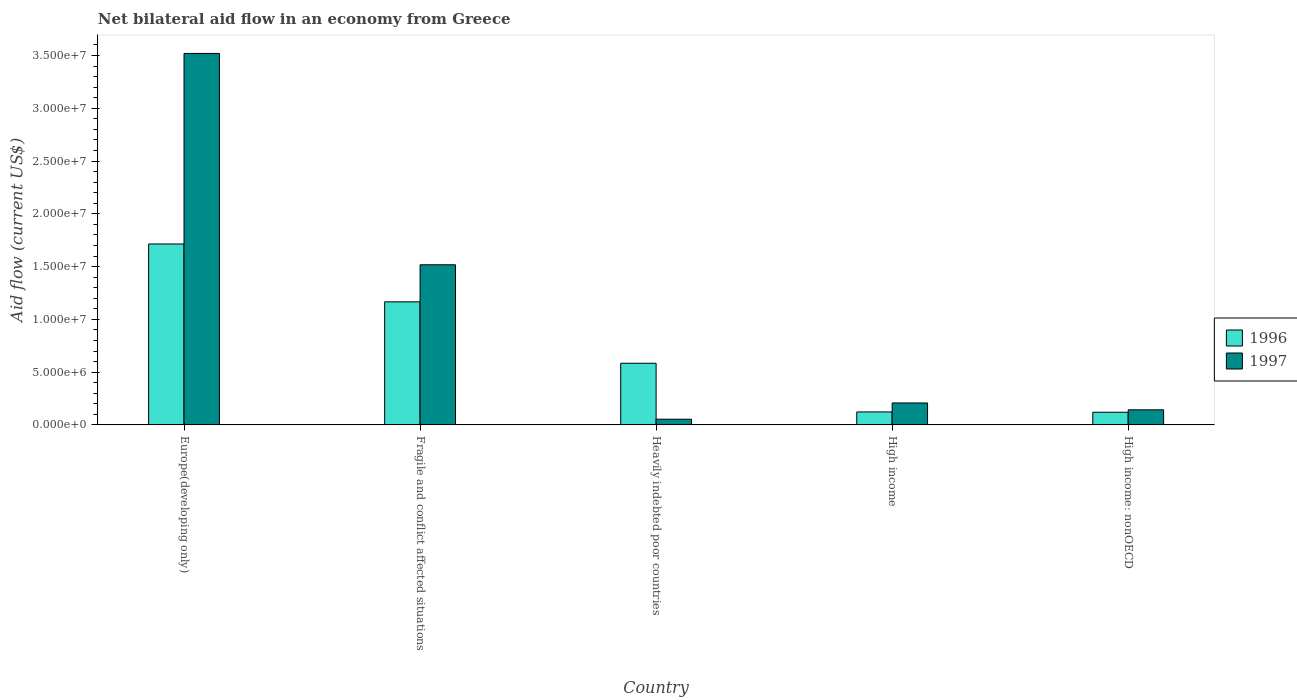Are the number of bars per tick equal to the number of legend labels?
Your answer should be very brief. Yes. Are the number of bars on each tick of the X-axis equal?
Your response must be concise. Yes. How many bars are there on the 4th tick from the left?
Keep it short and to the point. 2. What is the label of the 3rd group of bars from the left?
Ensure brevity in your answer.  Heavily indebted poor countries. In how many cases, is the number of bars for a given country not equal to the number of legend labels?
Ensure brevity in your answer.  0. What is the net bilateral aid flow in 1997 in Europe(developing only)?
Keep it short and to the point. 3.52e+07. Across all countries, what is the maximum net bilateral aid flow in 1996?
Provide a succinct answer. 1.71e+07. Across all countries, what is the minimum net bilateral aid flow in 1997?
Your answer should be very brief. 5.40e+05. In which country was the net bilateral aid flow in 1996 maximum?
Your answer should be compact. Europe(developing only). In which country was the net bilateral aid flow in 1996 minimum?
Provide a succinct answer. High income: nonOECD. What is the total net bilateral aid flow in 1997 in the graph?
Make the answer very short. 5.44e+07. What is the difference between the net bilateral aid flow in 1997 in Fragile and conflict affected situations and that in High income?
Ensure brevity in your answer.  1.31e+07. What is the difference between the net bilateral aid flow in 1996 in Heavily indebted poor countries and the net bilateral aid flow in 1997 in Europe(developing only)?
Offer a terse response. -2.94e+07. What is the average net bilateral aid flow in 1997 per country?
Ensure brevity in your answer.  1.09e+07. What is the difference between the net bilateral aid flow of/in 1997 and net bilateral aid flow of/in 1996 in Fragile and conflict affected situations?
Offer a terse response. 3.51e+06. In how many countries, is the net bilateral aid flow in 1997 greater than 2000000 US$?
Provide a succinct answer. 3. What is the ratio of the net bilateral aid flow in 1996 in High income to that in High income: nonOECD?
Your answer should be very brief. 1.02. Is the net bilateral aid flow in 1996 in Europe(developing only) less than that in Fragile and conflict affected situations?
Offer a very short reply. No. Is the difference between the net bilateral aid flow in 1997 in Fragile and conflict affected situations and High income: nonOECD greater than the difference between the net bilateral aid flow in 1996 in Fragile and conflict affected situations and High income: nonOECD?
Offer a very short reply. Yes. What is the difference between the highest and the second highest net bilateral aid flow in 1997?
Offer a very short reply. 3.31e+07. What is the difference between the highest and the lowest net bilateral aid flow in 1997?
Provide a succinct answer. 3.46e+07. Is the sum of the net bilateral aid flow in 1997 in Heavily indebted poor countries and High income greater than the maximum net bilateral aid flow in 1996 across all countries?
Ensure brevity in your answer.  No. What does the 2nd bar from the left in Europe(developing only) represents?
Ensure brevity in your answer.  1997. How many bars are there?
Your answer should be very brief. 10. Are all the bars in the graph horizontal?
Your response must be concise. No. What is the difference between two consecutive major ticks on the Y-axis?
Provide a succinct answer. 5.00e+06. Where does the legend appear in the graph?
Keep it short and to the point. Center right. How are the legend labels stacked?
Ensure brevity in your answer.  Vertical. What is the title of the graph?
Your response must be concise. Net bilateral aid flow in an economy from Greece. What is the label or title of the Y-axis?
Your answer should be compact. Aid flow (current US$). What is the Aid flow (current US$) of 1996 in Europe(developing only)?
Provide a short and direct response. 1.71e+07. What is the Aid flow (current US$) in 1997 in Europe(developing only)?
Offer a very short reply. 3.52e+07. What is the Aid flow (current US$) of 1996 in Fragile and conflict affected situations?
Offer a very short reply. 1.17e+07. What is the Aid flow (current US$) of 1997 in Fragile and conflict affected situations?
Provide a short and direct response. 1.52e+07. What is the Aid flow (current US$) in 1996 in Heavily indebted poor countries?
Provide a succinct answer. 5.84e+06. What is the Aid flow (current US$) in 1997 in Heavily indebted poor countries?
Ensure brevity in your answer.  5.40e+05. What is the Aid flow (current US$) in 1996 in High income?
Keep it short and to the point. 1.23e+06. What is the Aid flow (current US$) in 1997 in High income?
Provide a succinct answer. 2.08e+06. What is the Aid flow (current US$) in 1996 in High income: nonOECD?
Ensure brevity in your answer.  1.20e+06. What is the Aid flow (current US$) of 1997 in High income: nonOECD?
Your response must be concise. 1.43e+06. Across all countries, what is the maximum Aid flow (current US$) in 1996?
Ensure brevity in your answer.  1.71e+07. Across all countries, what is the maximum Aid flow (current US$) in 1997?
Make the answer very short. 3.52e+07. Across all countries, what is the minimum Aid flow (current US$) in 1996?
Your answer should be compact. 1.20e+06. Across all countries, what is the minimum Aid flow (current US$) of 1997?
Provide a short and direct response. 5.40e+05. What is the total Aid flow (current US$) in 1996 in the graph?
Ensure brevity in your answer.  3.71e+07. What is the total Aid flow (current US$) of 1997 in the graph?
Provide a succinct answer. 5.44e+07. What is the difference between the Aid flow (current US$) of 1996 in Europe(developing only) and that in Fragile and conflict affected situations?
Offer a very short reply. 5.48e+06. What is the difference between the Aid flow (current US$) of 1997 in Europe(developing only) and that in Fragile and conflict affected situations?
Ensure brevity in your answer.  2.00e+07. What is the difference between the Aid flow (current US$) of 1996 in Europe(developing only) and that in Heavily indebted poor countries?
Offer a very short reply. 1.13e+07. What is the difference between the Aid flow (current US$) of 1997 in Europe(developing only) and that in Heavily indebted poor countries?
Your answer should be very brief. 3.46e+07. What is the difference between the Aid flow (current US$) in 1996 in Europe(developing only) and that in High income?
Provide a short and direct response. 1.59e+07. What is the difference between the Aid flow (current US$) of 1997 in Europe(developing only) and that in High income?
Offer a terse response. 3.31e+07. What is the difference between the Aid flow (current US$) in 1996 in Europe(developing only) and that in High income: nonOECD?
Ensure brevity in your answer.  1.59e+07. What is the difference between the Aid flow (current US$) of 1997 in Europe(developing only) and that in High income: nonOECD?
Offer a terse response. 3.38e+07. What is the difference between the Aid flow (current US$) of 1996 in Fragile and conflict affected situations and that in Heavily indebted poor countries?
Make the answer very short. 5.82e+06. What is the difference between the Aid flow (current US$) of 1997 in Fragile and conflict affected situations and that in Heavily indebted poor countries?
Your response must be concise. 1.46e+07. What is the difference between the Aid flow (current US$) of 1996 in Fragile and conflict affected situations and that in High income?
Provide a short and direct response. 1.04e+07. What is the difference between the Aid flow (current US$) in 1997 in Fragile and conflict affected situations and that in High income?
Give a very brief answer. 1.31e+07. What is the difference between the Aid flow (current US$) of 1996 in Fragile and conflict affected situations and that in High income: nonOECD?
Offer a very short reply. 1.05e+07. What is the difference between the Aid flow (current US$) of 1997 in Fragile and conflict affected situations and that in High income: nonOECD?
Provide a succinct answer. 1.37e+07. What is the difference between the Aid flow (current US$) of 1996 in Heavily indebted poor countries and that in High income?
Keep it short and to the point. 4.61e+06. What is the difference between the Aid flow (current US$) of 1997 in Heavily indebted poor countries and that in High income?
Your answer should be very brief. -1.54e+06. What is the difference between the Aid flow (current US$) of 1996 in Heavily indebted poor countries and that in High income: nonOECD?
Your answer should be very brief. 4.64e+06. What is the difference between the Aid flow (current US$) in 1997 in Heavily indebted poor countries and that in High income: nonOECD?
Offer a terse response. -8.90e+05. What is the difference between the Aid flow (current US$) of 1997 in High income and that in High income: nonOECD?
Your response must be concise. 6.50e+05. What is the difference between the Aid flow (current US$) of 1996 in Europe(developing only) and the Aid flow (current US$) of 1997 in Fragile and conflict affected situations?
Keep it short and to the point. 1.97e+06. What is the difference between the Aid flow (current US$) of 1996 in Europe(developing only) and the Aid flow (current US$) of 1997 in Heavily indebted poor countries?
Give a very brief answer. 1.66e+07. What is the difference between the Aid flow (current US$) in 1996 in Europe(developing only) and the Aid flow (current US$) in 1997 in High income?
Ensure brevity in your answer.  1.51e+07. What is the difference between the Aid flow (current US$) of 1996 in Europe(developing only) and the Aid flow (current US$) of 1997 in High income: nonOECD?
Your response must be concise. 1.57e+07. What is the difference between the Aid flow (current US$) in 1996 in Fragile and conflict affected situations and the Aid flow (current US$) in 1997 in Heavily indebted poor countries?
Ensure brevity in your answer.  1.11e+07. What is the difference between the Aid flow (current US$) of 1996 in Fragile and conflict affected situations and the Aid flow (current US$) of 1997 in High income?
Ensure brevity in your answer.  9.58e+06. What is the difference between the Aid flow (current US$) in 1996 in Fragile and conflict affected situations and the Aid flow (current US$) in 1997 in High income: nonOECD?
Provide a short and direct response. 1.02e+07. What is the difference between the Aid flow (current US$) in 1996 in Heavily indebted poor countries and the Aid flow (current US$) in 1997 in High income?
Provide a succinct answer. 3.76e+06. What is the difference between the Aid flow (current US$) of 1996 in Heavily indebted poor countries and the Aid flow (current US$) of 1997 in High income: nonOECD?
Offer a terse response. 4.41e+06. What is the difference between the Aid flow (current US$) of 1996 in High income and the Aid flow (current US$) of 1997 in High income: nonOECD?
Make the answer very short. -2.00e+05. What is the average Aid flow (current US$) in 1996 per country?
Offer a terse response. 7.41e+06. What is the average Aid flow (current US$) in 1997 per country?
Offer a terse response. 1.09e+07. What is the difference between the Aid flow (current US$) in 1996 and Aid flow (current US$) in 1997 in Europe(developing only)?
Offer a terse response. -1.80e+07. What is the difference between the Aid flow (current US$) of 1996 and Aid flow (current US$) of 1997 in Fragile and conflict affected situations?
Your response must be concise. -3.51e+06. What is the difference between the Aid flow (current US$) of 1996 and Aid flow (current US$) of 1997 in Heavily indebted poor countries?
Make the answer very short. 5.30e+06. What is the difference between the Aid flow (current US$) of 1996 and Aid flow (current US$) of 1997 in High income?
Keep it short and to the point. -8.50e+05. What is the difference between the Aid flow (current US$) in 1996 and Aid flow (current US$) in 1997 in High income: nonOECD?
Make the answer very short. -2.30e+05. What is the ratio of the Aid flow (current US$) in 1996 in Europe(developing only) to that in Fragile and conflict affected situations?
Provide a succinct answer. 1.47. What is the ratio of the Aid flow (current US$) in 1997 in Europe(developing only) to that in Fragile and conflict affected situations?
Your answer should be compact. 2.32. What is the ratio of the Aid flow (current US$) in 1996 in Europe(developing only) to that in Heavily indebted poor countries?
Give a very brief answer. 2.93. What is the ratio of the Aid flow (current US$) of 1997 in Europe(developing only) to that in Heavily indebted poor countries?
Give a very brief answer. 65.17. What is the ratio of the Aid flow (current US$) in 1996 in Europe(developing only) to that in High income?
Make the answer very short. 13.94. What is the ratio of the Aid flow (current US$) in 1997 in Europe(developing only) to that in High income?
Provide a succinct answer. 16.92. What is the ratio of the Aid flow (current US$) in 1996 in Europe(developing only) to that in High income: nonOECD?
Offer a terse response. 14.28. What is the ratio of the Aid flow (current US$) in 1997 in Europe(developing only) to that in High income: nonOECD?
Provide a short and direct response. 24.61. What is the ratio of the Aid flow (current US$) of 1996 in Fragile and conflict affected situations to that in Heavily indebted poor countries?
Keep it short and to the point. 2. What is the ratio of the Aid flow (current US$) in 1997 in Fragile and conflict affected situations to that in Heavily indebted poor countries?
Your answer should be compact. 28.09. What is the ratio of the Aid flow (current US$) in 1996 in Fragile and conflict affected situations to that in High income?
Your answer should be compact. 9.48. What is the ratio of the Aid flow (current US$) of 1997 in Fragile and conflict affected situations to that in High income?
Your answer should be very brief. 7.29. What is the ratio of the Aid flow (current US$) in 1996 in Fragile and conflict affected situations to that in High income: nonOECD?
Provide a short and direct response. 9.72. What is the ratio of the Aid flow (current US$) of 1997 in Fragile and conflict affected situations to that in High income: nonOECD?
Make the answer very short. 10.61. What is the ratio of the Aid flow (current US$) in 1996 in Heavily indebted poor countries to that in High income?
Give a very brief answer. 4.75. What is the ratio of the Aid flow (current US$) of 1997 in Heavily indebted poor countries to that in High income?
Provide a succinct answer. 0.26. What is the ratio of the Aid flow (current US$) in 1996 in Heavily indebted poor countries to that in High income: nonOECD?
Your answer should be very brief. 4.87. What is the ratio of the Aid flow (current US$) in 1997 in Heavily indebted poor countries to that in High income: nonOECD?
Provide a succinct answer. 0.38. What is the ratio of the Aid flow (current US$) in 1997 in High income to that in High income: nonOECD?
Provide a short and direct response. 1.45. What is the difference between the highest and the second highest Aid flow (current US$) of 1996?
Give a very brief answer. 5.48e+06. What is the difference between the highest and the second highest Aid flow (current US$) of 1997?
Make the answer very short. 2.00e+07. What is the difference between the highest and the lowest Aid flow (current US$) of 1996?
Provide a succinct answer. 1.59e+07. What is the difference between the highest and the lowest Aid flow (current US$) of 1997?
Your answer should be very brief. 3.46e+07. 